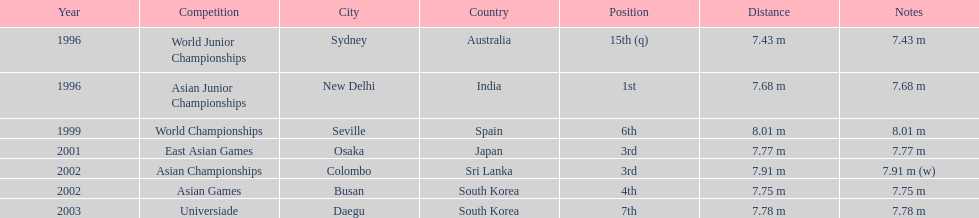What was the only competition where this competitor achieved 1st place? Asian Junior Championships. 